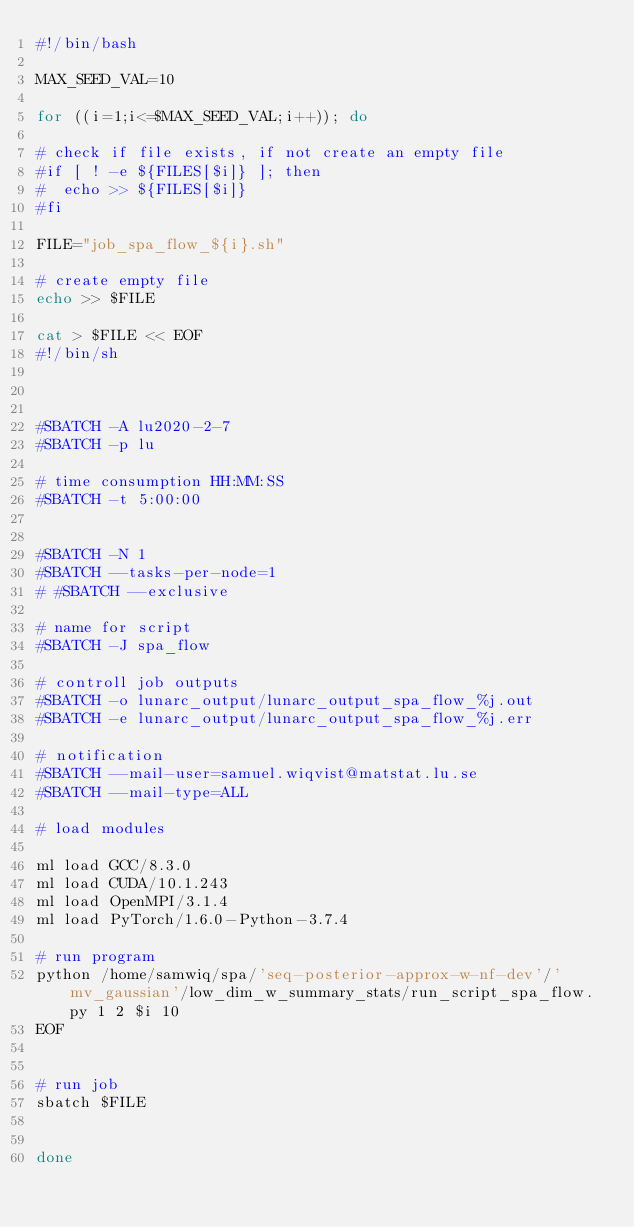<code> <loc_0><loc_0><loc_500><loc_500><_Bash_>#!/bin/bash

MAX_SEED_VAL=10

for ((i=1;i<=$MAX_SEED_VAL;i++)); do

# check if file exists, if not create an empty file
#if [ ! -e ${FILES[$i]} ]; then
#  echo >> ${FILES[$i]}
#fi

FILE="job_spa_flow_${i}.sh"

# create empty file
echo >> $FILE

cat > $FILE << EOF
#!/bin/sh



#SBATCH -A lu2020-2-7
#SBATCH -p lu

# time consumption HH:MM:SS
#SBATCH -t 5:00:00


#SBATCH -N 1
#SBATCH --tasks-per-node=1
# #SBATCH --exclusive

# name for script
#SBATCH -J spa_flow

# controll job outputs
#SBATCH -o lunarc_output/lunarc_output_spa_flow_%j.out
#SBATCH -e lunarc_output/lunarc_output_spa_flow_%j.err

# notification
#SBATCH --mail-user=samuel.wiqvist@matstat.lu.se
#SBATCH --mail-type=ALL

# load modules

ml load GCC/8.3.0
ml load CUDA/10.1.243
ml load OpenMPI/3.1.4
ml load PyTorch/1.6.0-Python-3.7.4

# run program
python /home/samwiq/spa/'seq-posterior-approx-w-nf-dev'/'mv_gaussian'/low_dim_w_summary_stats/run_script_spa_flow.py 1 2 $i 10
EOF


# run job
sbatch $FILE


done
</code> 